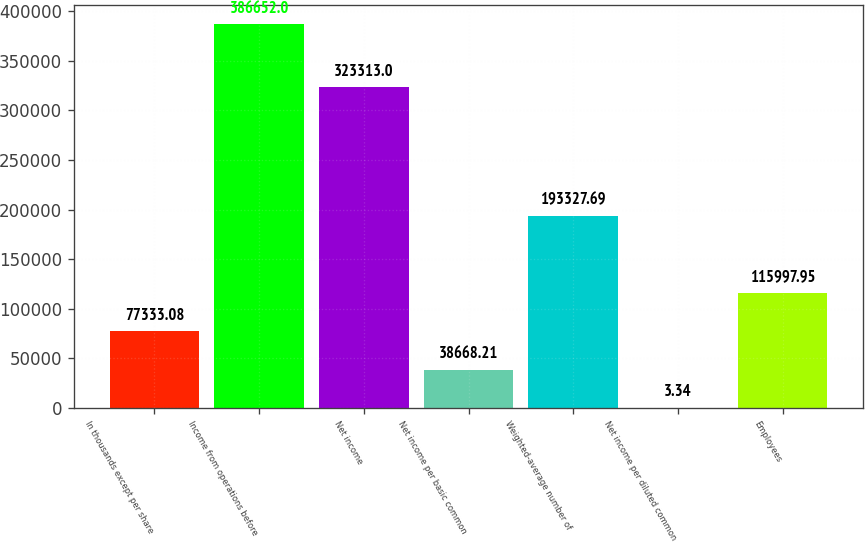<chart> <loc_0><loc_0><loc_500><loc_500><bar_chart><fcel>In thousands except per share<fcel>Income from operations before<fcel>Net income<fcel>Net income per basic common<fcel>Weighted-average number of<fcel>Net income per diluted common<fcel>Employees<nl><fcel>77333.1<fcel>386652<fcel>323313<fcel>38668.2<fcel>193328<fcel>3.34<fcel>115998<nl></chart> 